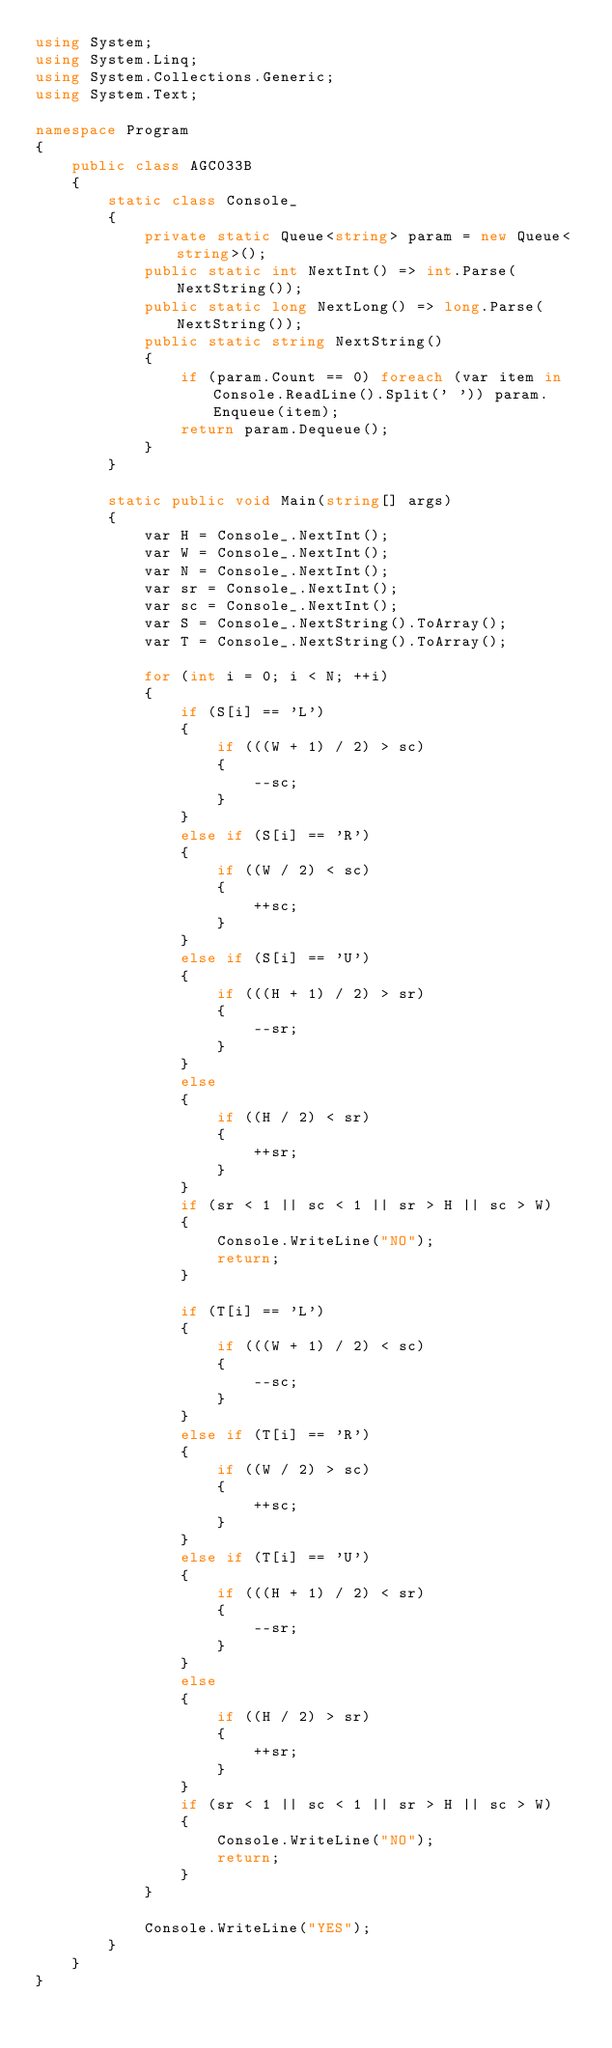<code> <loc_0><loc_0><loc_500><loc_500><_C#_>using System;
using System.Linq;
using System.Collections.Generic;
using System.Text;

namespace Program
{
    public class AGC033B
    {
        static class Console_
        {
            private static Queue<string> param = new Queue<string>();
            public static int NextInt() => int.Parse(NextString());
            public static long NextLong() => long.Parse(NextString());
            public static string NextString()
            {
                if (param.Count == 0) foreach (var item in Console.ReadLine().Split(' ')) param.Enqueue(item);
                return param.Dequeue();
            }
        }

        static public void Main(string[] args)
        {
            var H = Console_.NextInt();
            var W = Console_.NextInt();
            var N = Console_.NextInt();
            var sr = Console_.NextInt();
            var sc = Console_.NextInt();
            var S = Console_.NextString().ToArray();
            var T = Console_.NextString().ToArray();

            for (int i = 0; i < N; ++i)
            {
                if (S[i] == 'L')
                {
                    if (((W + 1) / 2) > sc)
                    {
                        --sc;
                    }
                }
                else if (S[i] == 'R')
                {
                    if ((W / 2) < sc)
                    {
                        ++sc;
                    }
                }
                else if (S[i] == 'U')
                {
                    if (((H + 1) / 2) > sr)
                    {
                        --sr;
                    }
                }
                else
                {
                    if ((H / 2) < sr)
                    {
                        ++sr;
                    }
                }
                if (sr < 1 || sc < 1 || sr > H || sc > W)
                {
                    Console.WriteLine("NO");
                    return;
                }

                if (T[i] == 'L')
                {
                    if (((W + 1) / 2) < sc)
                    {
                        --sc;
                    }
                }
                else if (T[i] == 'R')
                {
                    if ((W / 2) > sc)
                    {
                        ++sc;
                    }
                }
                else if (T[i] == 'U')
                {
                    if (((H + 1) / 2) < sr)
                    {
                        --sr;
                    }
                }
                else
                {
                    if ((H / 2) > sr)
                    {
                        ++sr;
                    }
                }
                if (sr < 1 || sc < 1 || sr > H || sc > W)
                {
                    Console.WriteLine("NO");
                    return;
                }
            }

            Console.WriteLine("YES");
        }
    }
}
</code> 